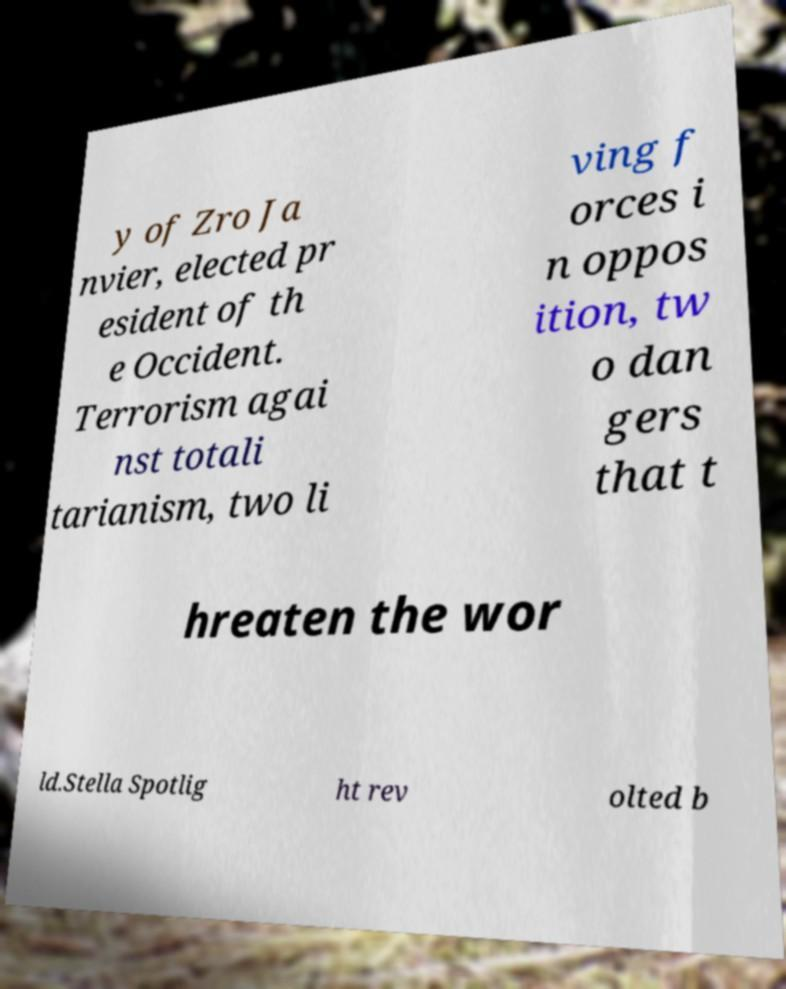What messages or text are displayed in this image? I need them in a readable, typed format. y of Zro Ja nvier, elected pr esident of th e Occident. Terrorism agai nst totali tarianism, two li ving f orces i n oppos ition, tw o dan gers that t hreaten the wor ld.Stella Spotlig ht rev olted b 